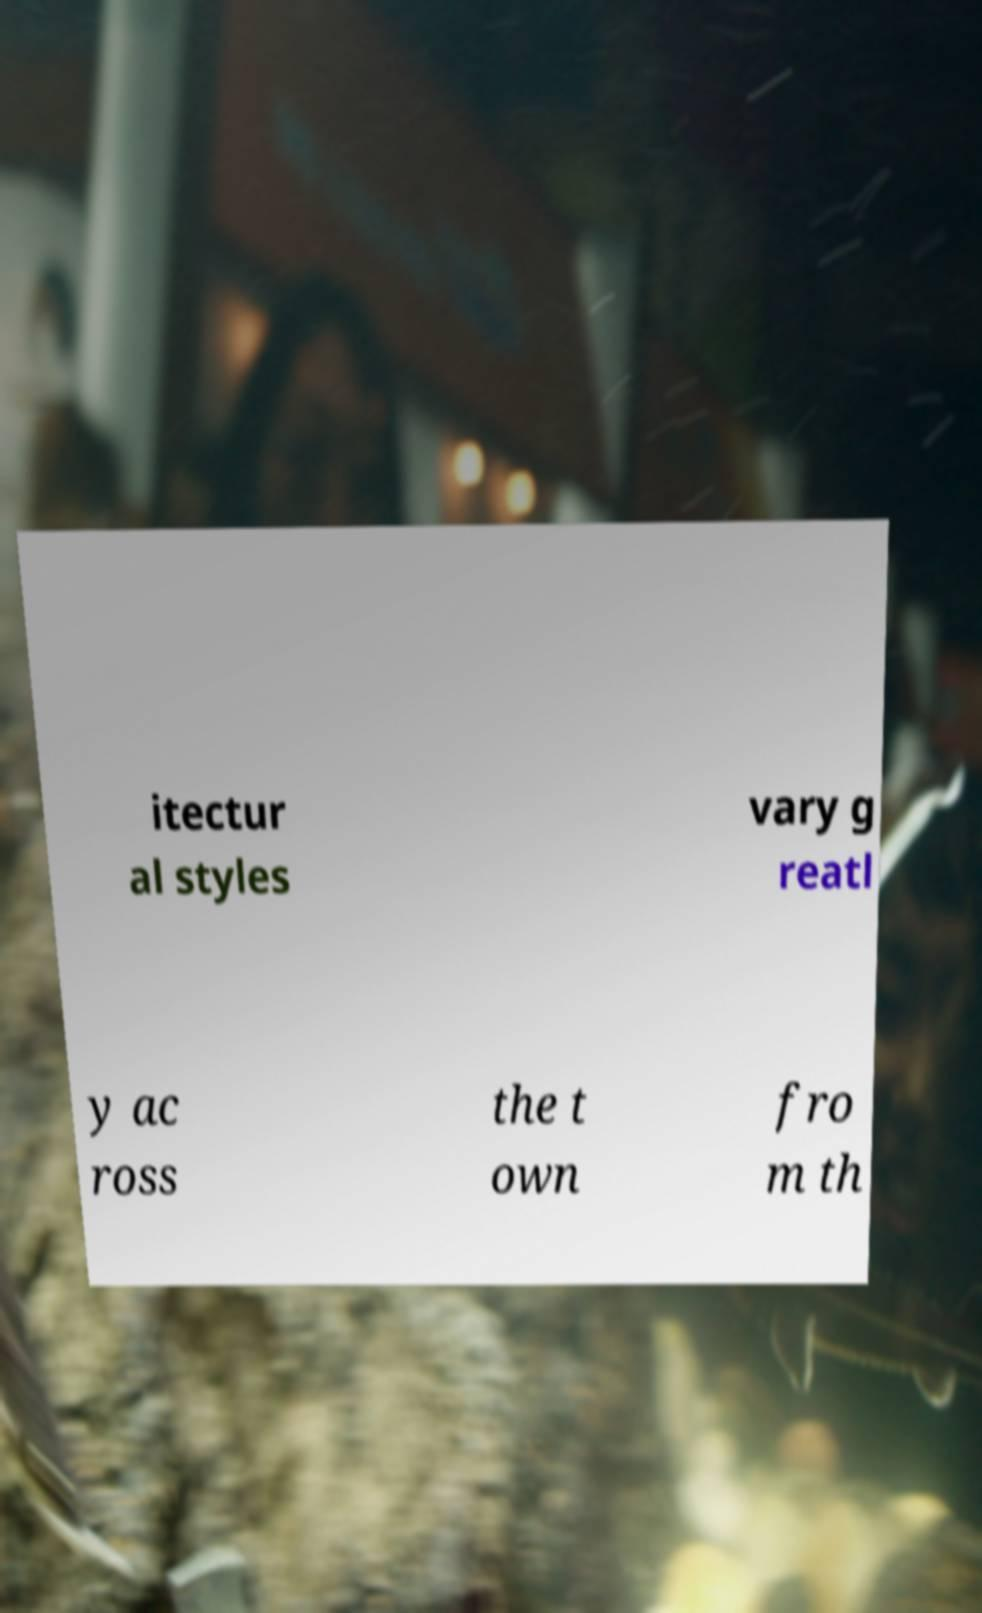Could you extract and type out the text from this image? itectur al styles vary g reatl y ac ross the t own fro m th 